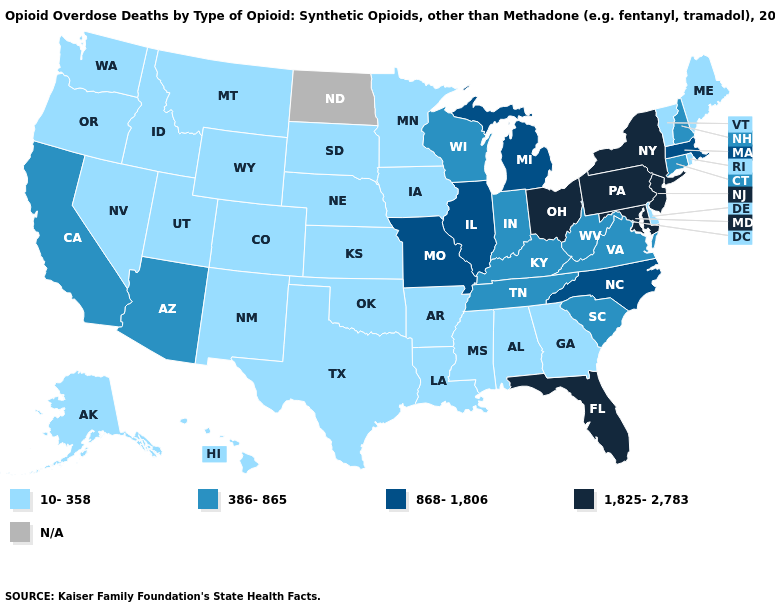What is the value of Tennessee?
Be succinct. 386-865. What is the value of Nebraska?
Keep it brief. 10-358. Is the legend a continuous bar?
Give a very brief answer. No. Name the states that have a value in the range 868-1,806?
Answer briefly. Illinois, Massachusetts, Michigan, Missouri, North Carolina. Name the states that have a value in the range 386-865?
Be succinct. Arizona, California, Connecticut, Indiana, Kentucky, New Hampshire, South Carolina, Tennessee, Virginia, West Virginia, Wisconsin. Name the states that have a value in the range 10-358?
Be succinct. Alabama, Alaska, Arkansas, Colorado, Delaware, Georgia, Hawaii, Idaho, Iowa, Kansas, Louisiana, Maine, Minnesota, Mississippi, Montana, Nebraska, Nevada, New Mexico, Oklahoma, Oregon, Rhode Island, South Dakota, Texas, Utah, Vermont, Washington, Wyoming. Among the states that border Virginia , which have the highest value?
Short answer required. Maryland. What is the value of Georgia?
Answer briefly. 10-358. Among the states that border Ohio , does Pennsylvania have the highest value?
Be succinct. Yes. Among the states that border Nebraska , which have the lowest value?
Give a very brief answer. Colorado, Iowa, Kansas, South Dakota, Wyoming. Name the states that have a value in the range 386-865?
Be succinct. Arizona, California, Connecticut, Indiana, Kentucky, New Hampshire, South Carolina, Tennessee, Virginia, West Virginia, Wisconsin. Name the states that have a value in the range 10-358?
Give a very brief answer. Alabama, Alaska, Arkansas, Colorado, Delaware, Georgia, Hawaii, Idaho, Iowa, Kansas, Louisiana, Maine, Minnesota, Mississippi, Montana, Nebraska, Nevada, New Mexico, Oklahoma, Oregon, Rhode Island, South Dakota, Texas, Utah, Vermont, Washington, Wyoming. Among the states that border Wyoming , which have the lowest value?
Keep it brief. Colorado, Idaho, Montana, Nebraska, South Dakota, Utah. 